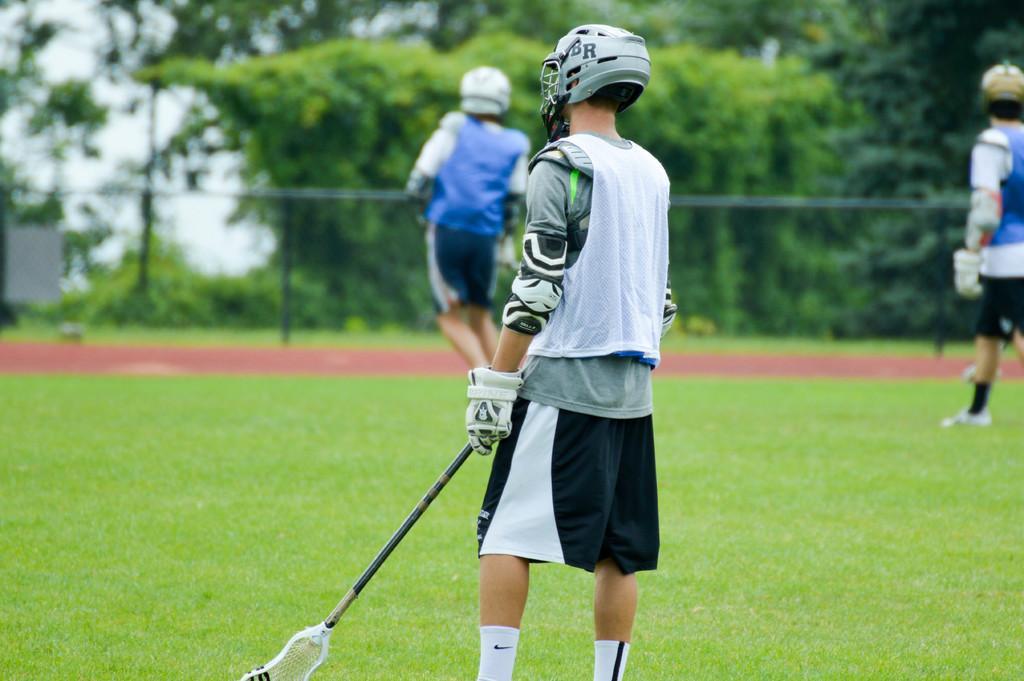Please provide a concise description of this image. In this image we can see some people on the ground and one person is wearing helmet and holding a stick in his hand. In the background of the image we can see trees, but it is in a blur. 